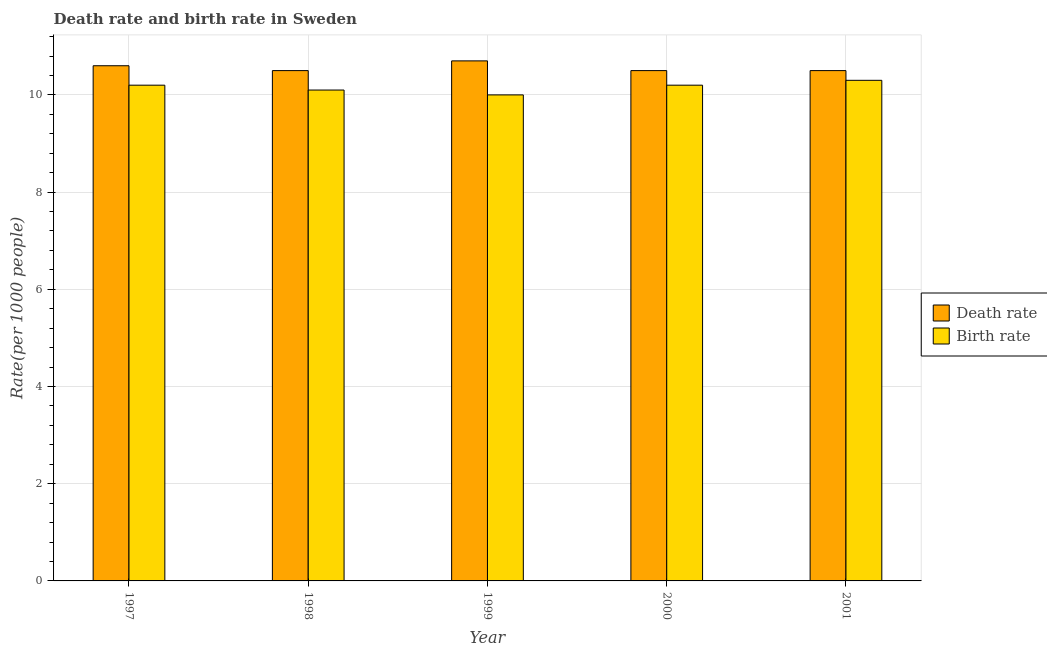How many different coloured bars are there?
Offer a terse response. 2. Are the number of bars on each tick of the X-axis equal?
Provide a succinct answer. Yes. How many bars are there on the 2nd tick from the left?
Your answer should be very brief. 2. How many bars are there on the 2nd tick from the right?
Your answer should be compact. 2. What is the death rate in 2000?
Ensure brevity in your answer.  10.5. Across all years, what is the minimum death rate?
Offer a terse response. 10.5. In which year was the death rate minimum?
Your response must be concise. 1998. What is the total death rate in the graph?
Your answer should be very brief. 52.8. What is the difference between the birth rate in 1998 and that in 2001?
Provide a short and direct response. -0.2. What is the average birth rate per year?
Provide a succinct answer. 10.16. In the year 1998, what is the difference between the birth rate and death rate?
Provide a short and direct response. 0. What is the ratio of the birth rate in 1999 to that in 2001?
Ensure brevity in your answer.  0.97. Is the difference between the birth rate in 1997 and 2001 greater than the difference between the death rate in 1997 and 2001?
Ensure brevity in your answer.  No. What is the difference between the highest and the second highest death rate?
Make the answer very short. 0.1. What is the difference between the highest and the lowest birth rate?
Provide a short and direct response. 0.3. Is the sum of the birth rate in 1998 and 1999 greater than the maximum death rate across all years?
Offer a terse response. Yes. What does the 2nd bar from the left in 2000 represents?
Your response must be concise. Birth rate. What does the 1st bar from the right in 1999 represents?
Provide a short and direct response. Birth rate. How many bars are there?
Your response must be concise. 10. Are all the bars in the graph horizontal?
Offer a very short reply. No. How many years are there in the graph?
Offer a very short reply. 5. What is the difference between two consecutive major ticks on the Y-axis?
Offer a very short reply. 2. Are the values on the major ticks of Y-axis written in scientific E-notation?
Provide a short and direct response. No. Does the graph contain grids?
Ensure brevity in your answer.  Yes. How are the legend labels stacked?
Offer a terse response. Vertical. What is the title of the graph?
Your answer should be compact. Death rate and birth rate in Sweden. Does "Imports" appear as one of the legend labels in the graph?
Offer a terse response. No. What is the label or title of the Y-axis?
Provide a short and direct response. Rate(per 1000 people). What is the Rate(per 1000 people) in Death rate in 1997?
Your answer should be compact. 10.6. What is the Rate(per 1000 people) in Birth rate in 1997?
Ensure brevity in your answer.  10.2. What is the Rate(per 1000 people) in Death rate in 1999?
Offer a terse response. 10.7. What is the Rate(per 1000 people) of Birth rate in 2000?
Offer a very short reply. 10.2. What is the Rate(per 1000 people) of Death rate in 2001?
Provide a succinct answer. 10.5. Across all years, what is the minimum Rate(per 1000 people) in Birth rate?
Offer a very short reply. 10. What is the total Rate(per 1000 people) of Death rate in the graph?
Your response must be concise. 52.8. What is the total Rate(per 1000 people) in Birth rate in the graph?
Your answer should be compact. 50.8. What is the difference between the Rate(per 1000 people) in Death rate in 1997 and that in 1998?
Provide a succinct answer. 0.1. What is the difference between the Rate(per 1000 people) of Death rate in 1997 and that in 1999?
Ensure brevity in your answer.  -0.1. What is the difference between the Rate(per 1000 people) of Birth rate in 1997 and that in 2000?
Provide a succinct answer. 0. What is the difference between the Rate(per 1000 people) in Death rate in 1998 and that in 1999?
Offer a very short reply. -0.2. What is the difference between the Rate(per 1000 people) of Birth rate in 1998 and that in 1999?
Offer a terse response. 0.1. What is the difference between the Rate(per 1000 people) of Death rate in 1998 and that in 2001?
Keep it short and to the point. 0. What is the difference between the Rate(per 1000 people) of Birth rate in 1999 and that in 2000?
Ensure brevity in your answer.  -0.2. What is the difference between the Rate(per 1000 people) of Death rate in 1999 and that in 2001?
Offer a very short reply. 0.2. What is the difference between the Rate(per 1000 people) of Birth rate in 1999 and that in 2001?
Make the answer very short. -0.3. What is the difference between the Rate(per 1000 people) in Death rate in 1997 and the Rate(per 1000 people) in Birth rate in 1998?
Give a very brief answer. 0.5. What is the difference between the Rate(per 1000 people) in Death rate in 1997 and the Rate(per 1000 people) in Birth rate in 1999?
Provide a short and direct response. 0.6. What is the difference between the Rate(per 1000 people) in Death rate in 1998 and the Rate(per 1000 people) in Birth rate in 2000?
Provide a succinct answer. 0.3. What is the average Rate(per 1000 people) in Death rate per year?
Provide a succinct answer. 10.56. What is the average Rate(per 1000 people) in Birth rate per year?
Make the answer very short. 10.16. In the year 1999, what is the difference between the Rate(per 1000 people) of Death rate and Rate(per 1000 people) of Birth rate?
Ensure brevity in your answer.  0.7. In the year 2000, what is the difference between the Rate(per 1000 people) of Death rate and Rate(per 1000 people) of Birth rate?
Offer a terse response. 0.3. In the year 2001, what is the difference between the Rate(per 1000 people) in Death rate and Rate(per 1000 people) in Birth rate?
Provide a short and direct response. 0.2. What is the ratio of the Rate(per 1000 people) in Death rate in 1997 to that in 1998?
Provide a short and direct response. 1.01. What is the ratio of the Rate(per 1000 people) of Birth rate in 1997 to that in 1998?
Give a very brief answer. 1.01. What is the ratio of the Rate(per 1000 people) in Death rate in 1997 to that in 1999?
Ensure brevity in your answer.  0.99. What is the ratio of the Rate(per 1000 people) in Birth rate in 1997 to that in 1999?
Provide a succinct answer. 1.02. What is the ratio of the Rate(per 1000 people) of Death rate in 1997 to that in 2000?
Your answer should be compact. 1.01. What is the ratio of the Rate(per 1000 people) in Death rate in 1997 to that in 2001?
Provide a short and direct response. 1.01. What is the ratio of the Rate(per 1000 people) in Birth rate in 1997 to that in 2001?
Provide a succinct answer. 0.99. What is the ratio of the Rate(per 1000 people) in Death rate in 1998 to that in 1999?
Offer a very short reply. 0.98. What is the ratio of the Rate(per 1000 people) of Birth rate in 1998 to that in 1999?
Your answer should be compact. 1.01. What is the ratio of the Rate(per 1000 people) of Birth rate in 1998 to that in 2000?
Your response must be concise. 0.99. What is the ratio of the Rate(per 1000 people) in Death rate in 1998 to that in 2001?
Offer a very short reply. 1. What is the ratio of the Rate(per 1000 people) of Birth rate in 1998 to that in 2001?
Your answer should be compact. 0.98. What is the ratio of the Rate(per 1000 people) in Death rate in 1999 to that in 2000?
Offer a very short reply. 1.02. What is the ratio of the Rate(per 1000 people) in Birth rate in 1999 to that in 2000?
Your answer should be compact. 0.98. What is the ratio of the Rate(per 1000 people) of Death rate in 1999 to that in 2001?
Offer a very short reply. 1.02. What is the ratio of the Rate(per 1000 people) in Birth rate in 1999 to that in 2001?
Offer a terse response. 0.97. What is the ratio of the Rate(per 1000 people) of Birth rate in 2000 to that in 2001?
Make the answer very short. 0.99. What is the difference between the highest and the second highest Rate(per 1000 people) in Death rate?
Your response must be concise. 0.1. What is the difference between the highest and the second highest Rate(per 1000 people) of Birth rate?
Ensure brevity in your answer.  0.1. 